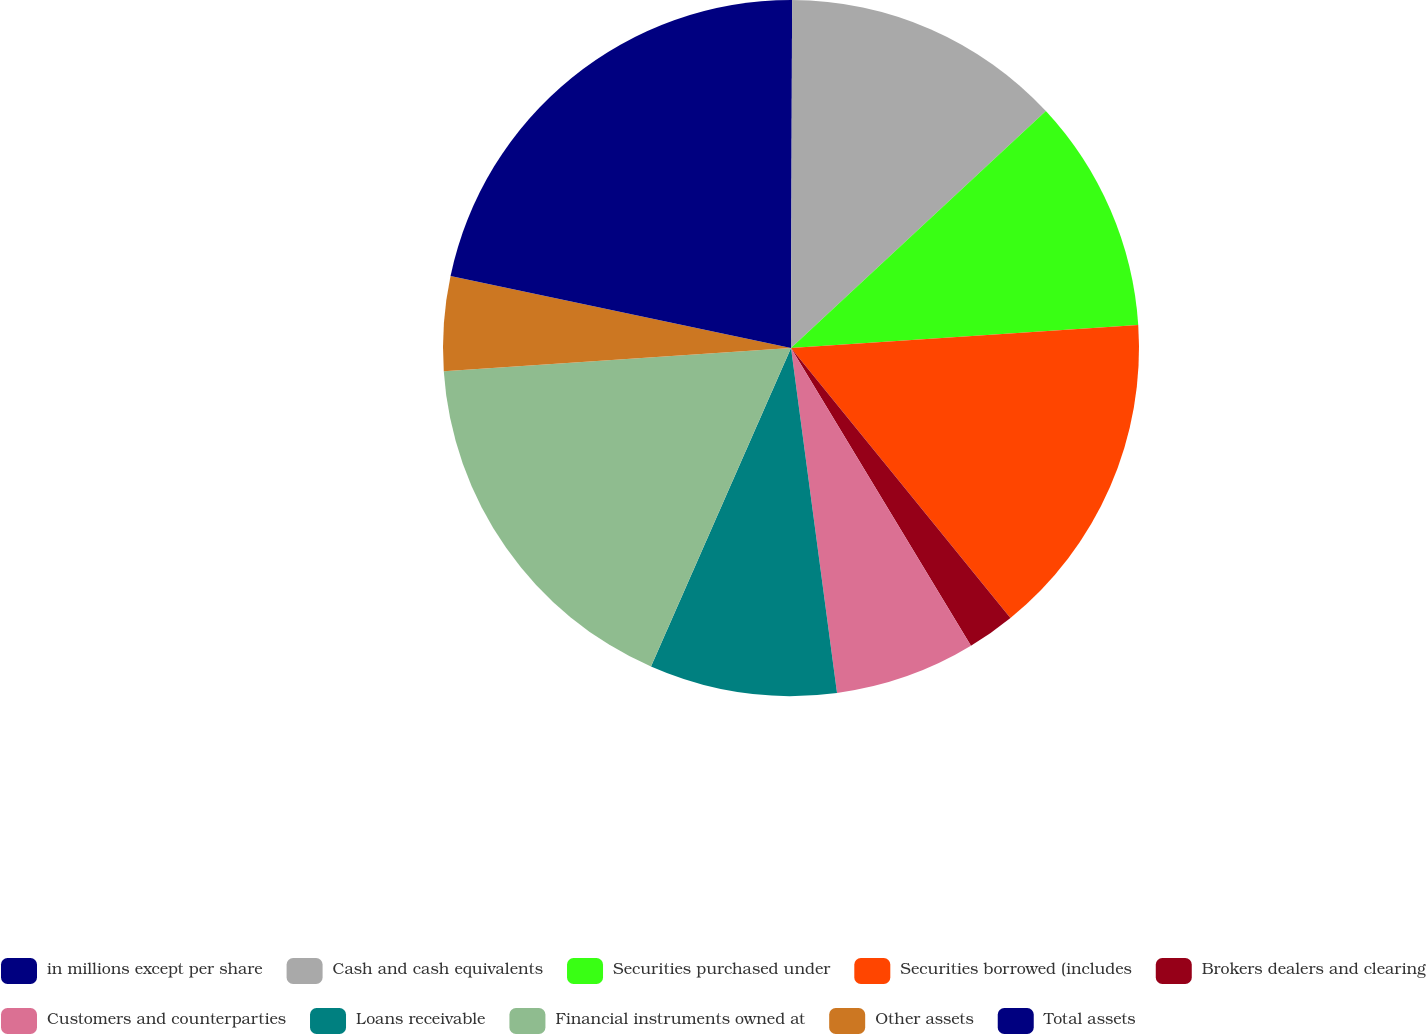Convert chart. <chart><loc_0><loc_0><loc_500><loc_500><pie_chart><fcel>in millions except per share<fcel>Cash and cash equivalents<fcel>Securities purchased under<fcel>Securities borrowed (includes<fcel>Brokers dealers and clearing<fcel>Customers and counterparties<fcel>Loans receivable<fcel>Financial instruments owned at<fcel>Other assets<fcel>Total assets<nl><fcel>0.05%<fcel>13.03%<fcel>10.87%<fcel>15.19%<fcel>2.21%<fcel>6.54%<fcel>8.7%<fcel>17.35%<fcel>4.38%<fcel>21.68%<nl></chart> 